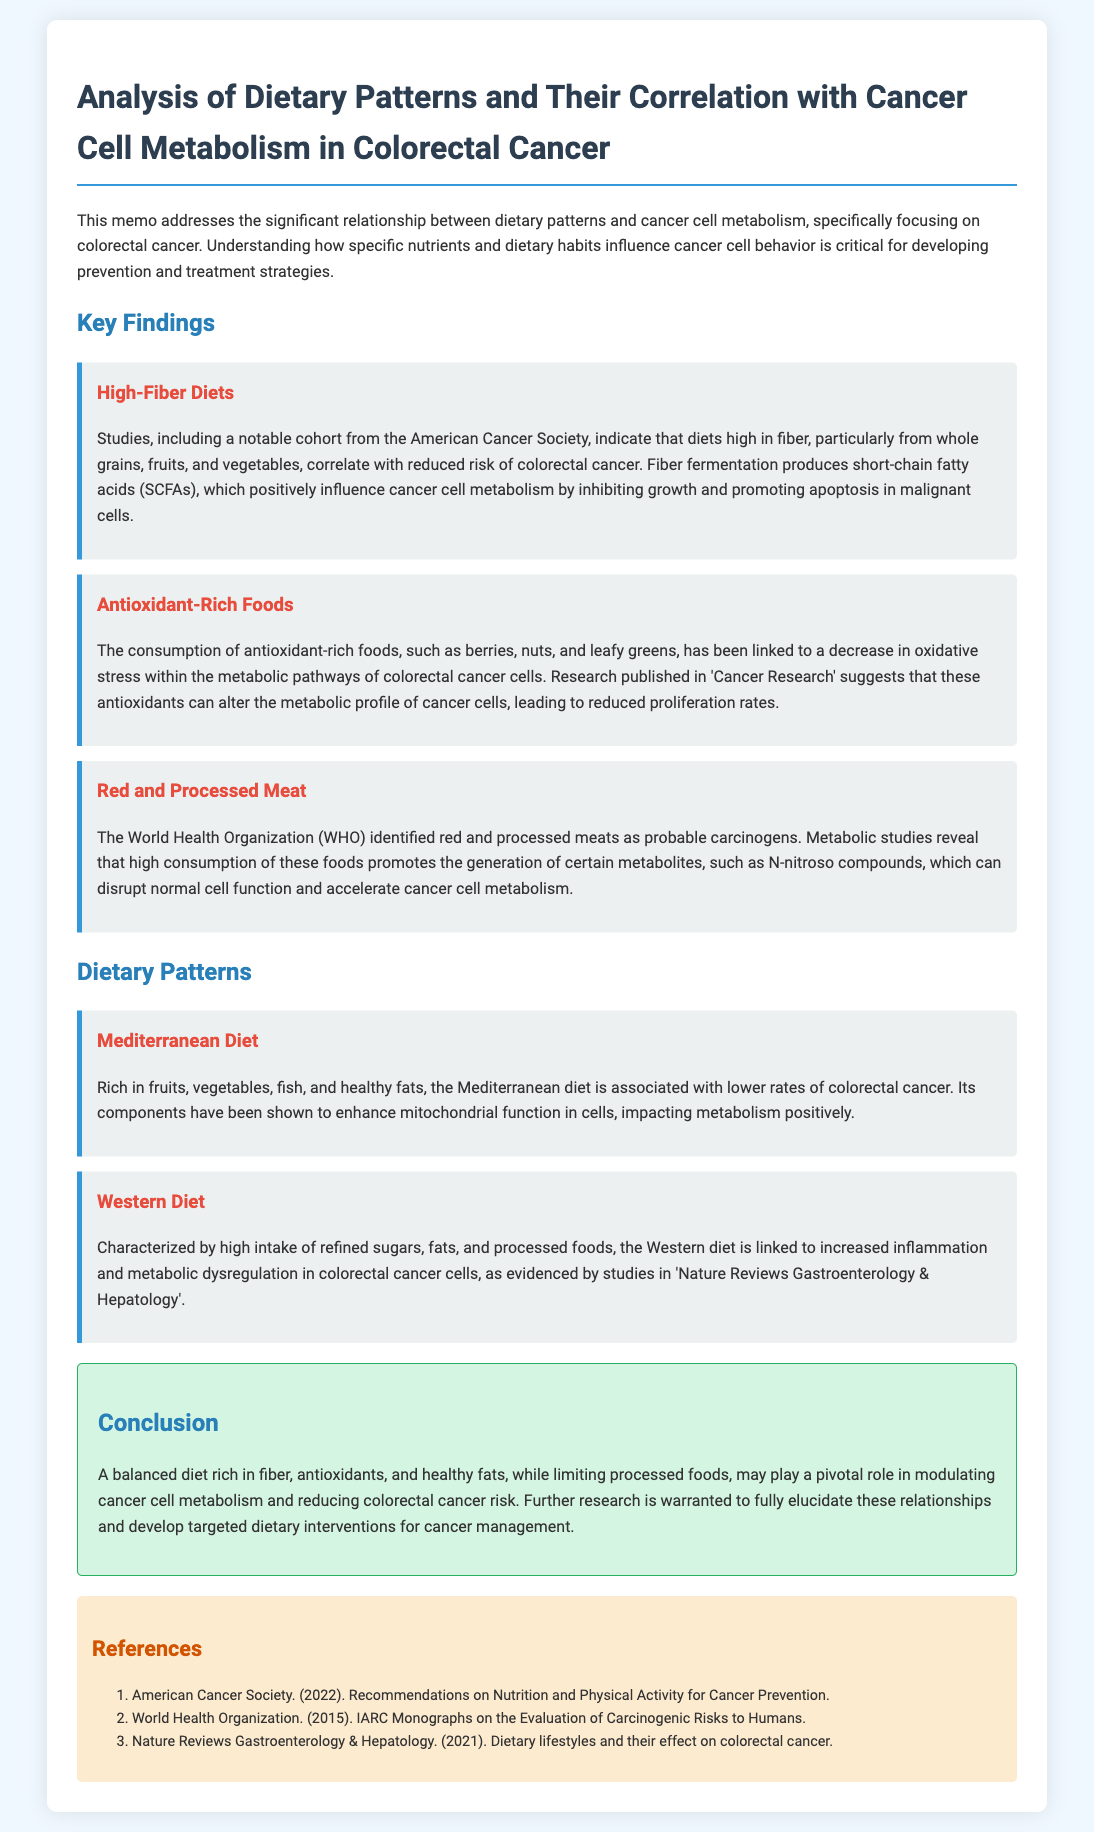What diet is associated with lower rates of colorectal cancer? The Mediterranean diet is specifically mentioned as being associated with lower rates of colorectal cancer due to its rich components.
Answer: Mediterranean diet Which type of food is identified as a probable carcinogen by WHO? The document states that red and processed meats are identified as probable carcinogens by the World Health Organization.
Answer: Red and processed meat What are SCFAs? The document mentions that fiber fermentation produces short-chain fatty acids, which positively influence cancer cell metabolism.
Answer: Short-chain fatty acids What effect do antioxidant-rich foods have on cancer cell metabolism? The consumption of antioxidant-rich foods is linked to a decrease in oxidative stress and altered metabolic profiles in colorectal cancer cells.
Answer: Decrease in oxidative stress According to the document, which dietary pattern is characterized by high intake of refined sugars? The Western diet is characterized by high intake of refined sugars, fats, and processed foods.
Answer: Western diet What is the main conclusion about dietary patterns in relation to colorectal cancer? The conclusion states that a balanced diet rich in fiber, antioxidants, and healthy fats may play a pivotal role in lowering colorectal cancer risk.
Answer: A balanced diet rich in fiber, antioxidants, and healthy fats What type of document is this? The structure and content indicate that this is a memo analyzing dietary patterns and their correlation with cancer cell metabolism.
Answer: Memo What journal published the research about the effect of dietary lifestyles on colorectal cancer? The document refers to research published in 'Nature Reviews Gastroenterology & Hepatology' on this topic.
Answer: Nature Reviews Gastroenterology & Hepatology 